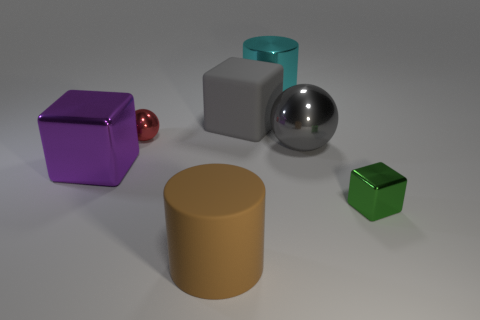Subtract all metallic blocks. How many blocks are left? 1 Subtract 1 blocks. How many blocks are left? 2 Add 2 rubber objects. How many objects exist? 9 Subtract all balls. How many objects are left? 5 Subtract 0 purple spheres. How many objects are left? 7 Subtract all small red cylinders. Subtract all tiny red spheres. How many objects are left? 6 Add 7 big metallic spheres. How many big metallic spheres are left? 8 Add 6 gray metallic objects. How many gray metallic objects exist? 7 